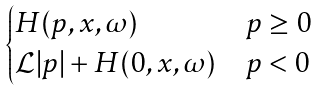<formula> <loc_0><loc_0><loc_500><loc_500>\begin{cases} H ( p , x , \omega ) & p \geq 0 \\ \mathcal { L } | p | + H ( 0 , x , \omega ) & p < 0 \end{cases}</formula> 